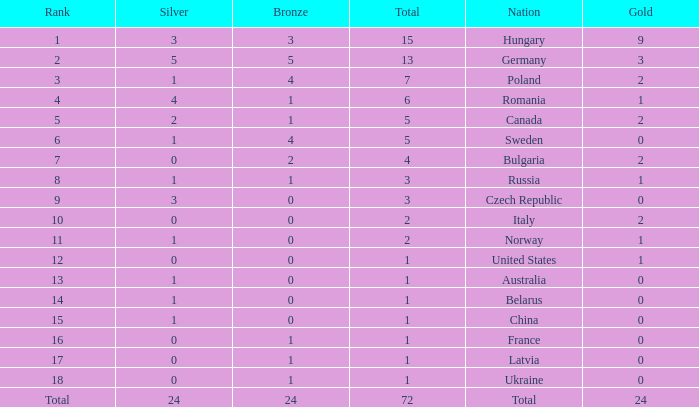I'm looking to parse the entire table for insights. Could you assist me with that? {'header': ['Rank', 'Silver', 'Bronze', 'Total', 'Nation', 'Gold'], 'rows': [['1', '3', '3', '15', 'Hungary', '9'], ['2', '5', '5', '13', 'Germany', '3'], ['3', '1', '4', '7', 'Poland', '2'], ['4', '4', '1', '6', 'Romania', '1'], ['5', '2', '1', '5', 'Canada', '2'], ['6', '1', '4', '5', 'Sweden', '0'], ['7', '0', '2', '4', 'Bulgaria', '2'], ['8', '1', '1', '3', 'Russia', '1'], ['9', '3', '0', '3', 'Czech Republic', '0'], ['10', '0', '0', '2', 'Italy', '2'], ['11', '1', '0', '2', 'Norway', '1'], ['12', '0', '0', '1', 'United States', '1'], ['13', '1', '0', '1', 'Australia', '0'], ['14', '1', '0', '1', 'Belarus', '0'], ['15', '1', '0', '1', 'China', '0'], ['16', '0', '1', '1', 'France', '0'], ['17', '0', '1', '1', 'Latvia', '0'], ['18', '0', '1', '1', 'Ukraine', '0'], ['Total', '24', '24', '72', 'Total', '24']]} How many golds have 3 as the rank, with a total greater than 7? 0.0. 